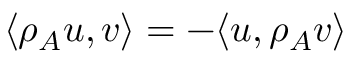Convert formula to latex. <formula><loc_0><loc_0><loc_500><loc_500>\langle \rho _ { A } u , v \rangle = - \langle u , \rho _ { A } v \rangle</formula> 